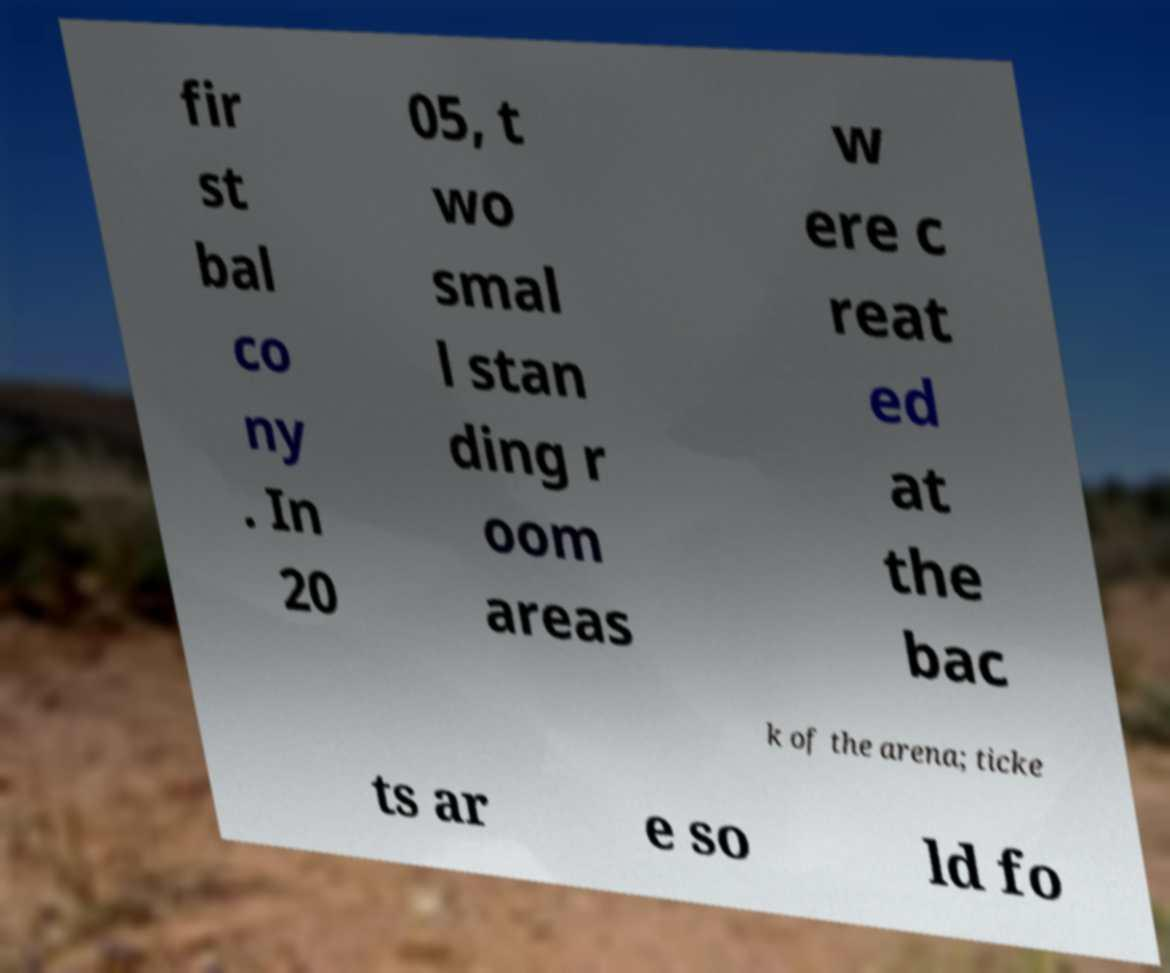I need the written content from this picture converted into text. Can you do that? fir st bal co ny . In 20 05, t wo smal l stan ding r oom areas w ere c reat ed at the bac k of the arena; ticke ts ar e so ld fo 